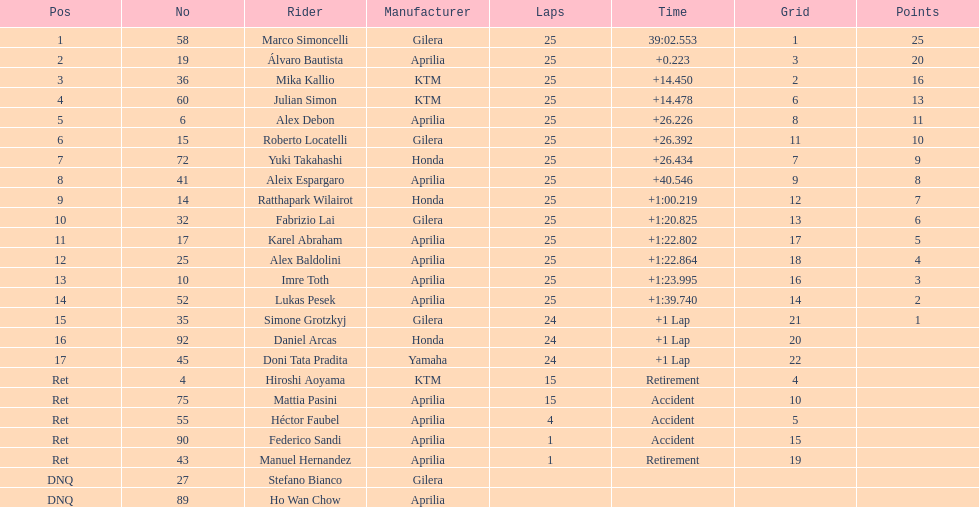Who executed the highest number of laps, marco simoncelli or hiroshi aoyama? Marco Simoncelli. 